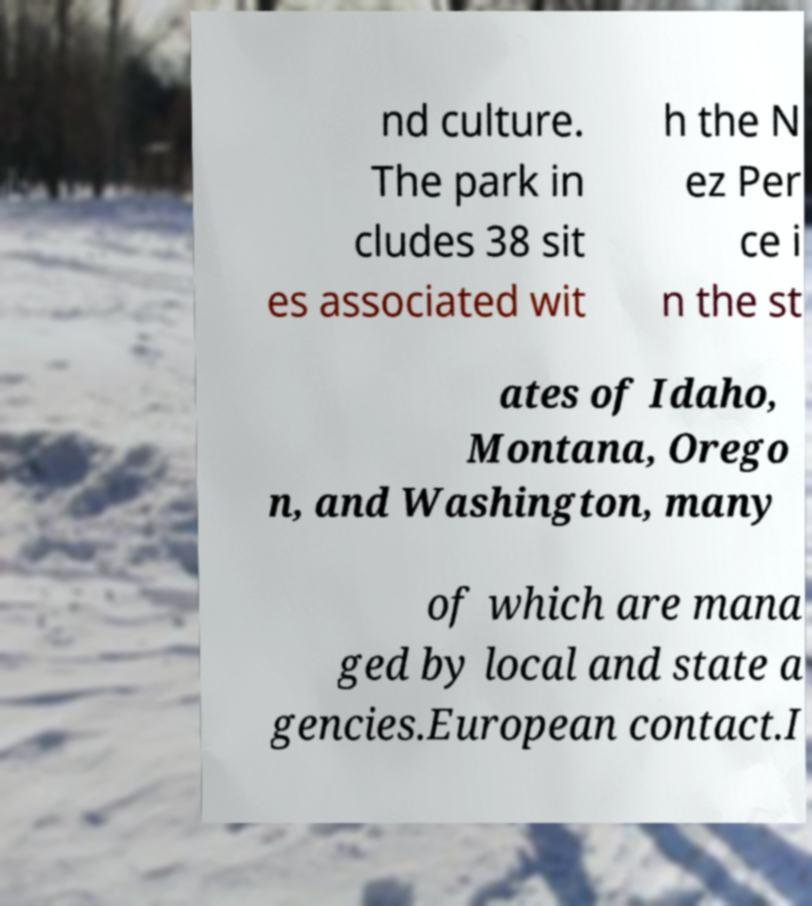There's text embedded in this image that I need extracted. Can you transcribe it verbatim? nd culture. The park in cludes 38 sit es associated wit h the N ez Per ce i n the st ates of Idaho, Montana, Orego n, and Washington, many of which are mana ged by local and state a gencies.European contact.I 